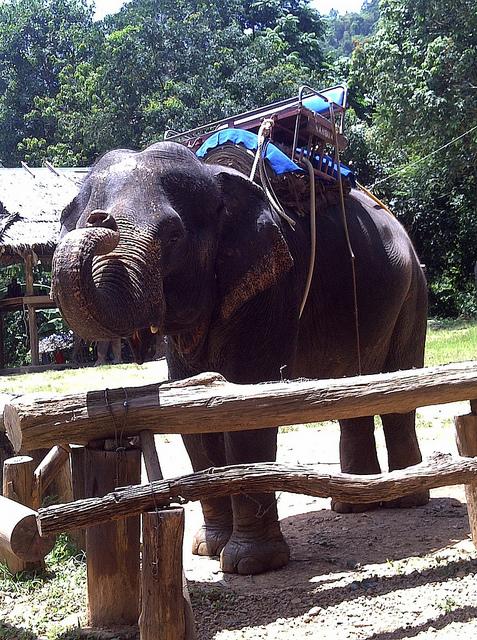Can you ride this elephant?
Write a very short answer. Yes. What is the fence made of?
Keep it brief. Wood. What type of animal is that?
Be succinct. Elephant. 